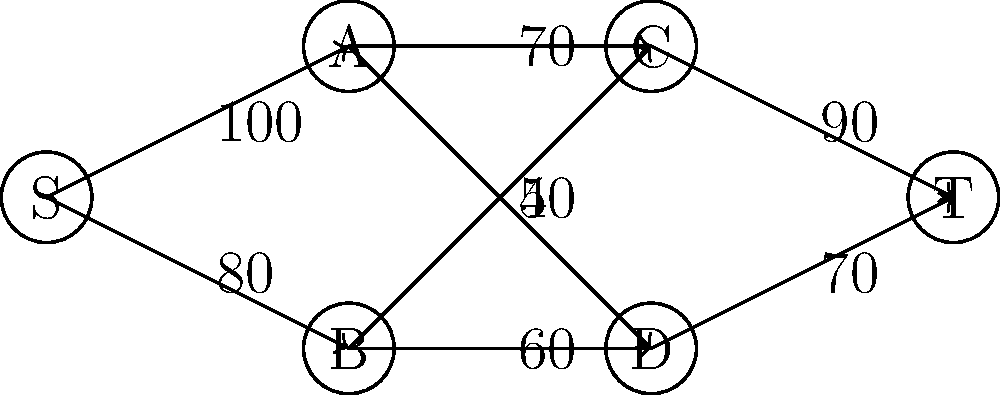As the organizer of a multi-stage comedy festival, you're tasked with determining the maximum flow of audience members through the venue. The graph represents different stages (nodes) and the capacity of paths between them (edges). S is the source (entrance), T is the sink (exit), and A, B, C, D are different performance areas. What is the maximum number of audience members that can flow through the venue from S to T? To solve this maximum flow problem, we'll use the Ford-Fulkerson algorithm:

1) Initialize flow to 0.

2) Find an augmenting path from S to T:
   - Path 1: S -> A -> C -> T (min capacity 90)
   Flow becomes 90.

3) Update residual graph and find another path:
   - Path 2: S -> B -> D -> T (min capacity 70)
   Flow becomes 90 + 70 = 160.

4) Update and find another path:
   - Path 3: S -> A -> D -> T (min capacity 50)
   Flow becomes 160 + 50 = 210.

5) Update and find another path:
   - Path 4: S -> B -> C -> T (min capacity 10)
   Flow becomes 210 + 10 = 220.

6) No more augmenting paths exist.

Therefore, the maximum flow is 220.

This solution pushes the boundaries by utilizing every possible path and maximizing the venue's capacity, aligning with the persona of a risk-taking professional.
Answer: 220 audience members 